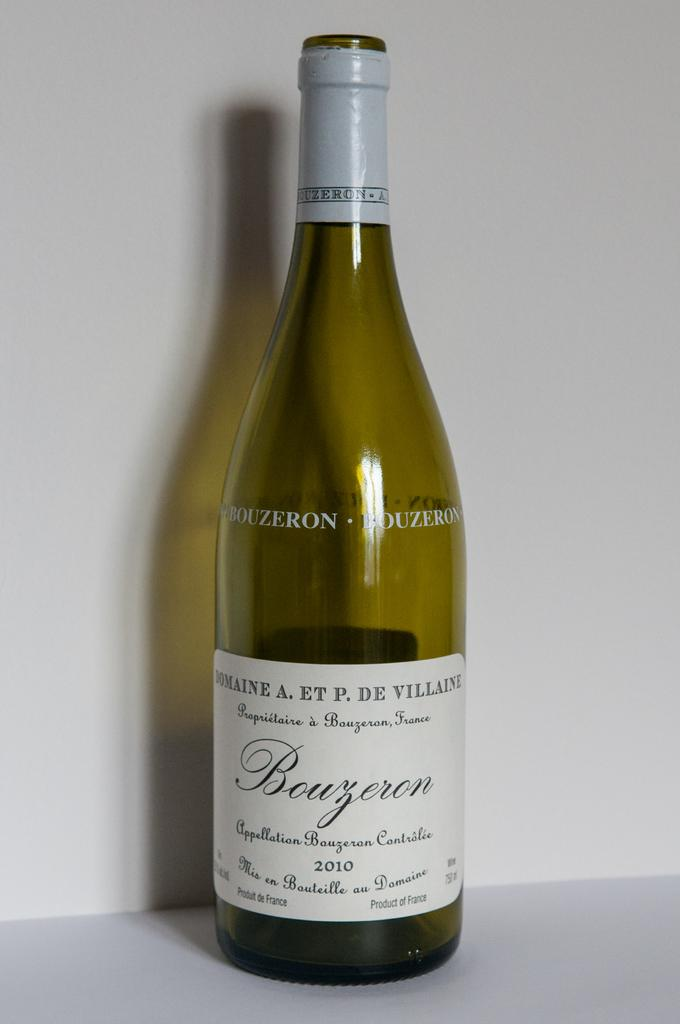Provide a one-sentence caption for the provided image. A 2010 Bouzoron wine bottle is being displayed in the picture. 